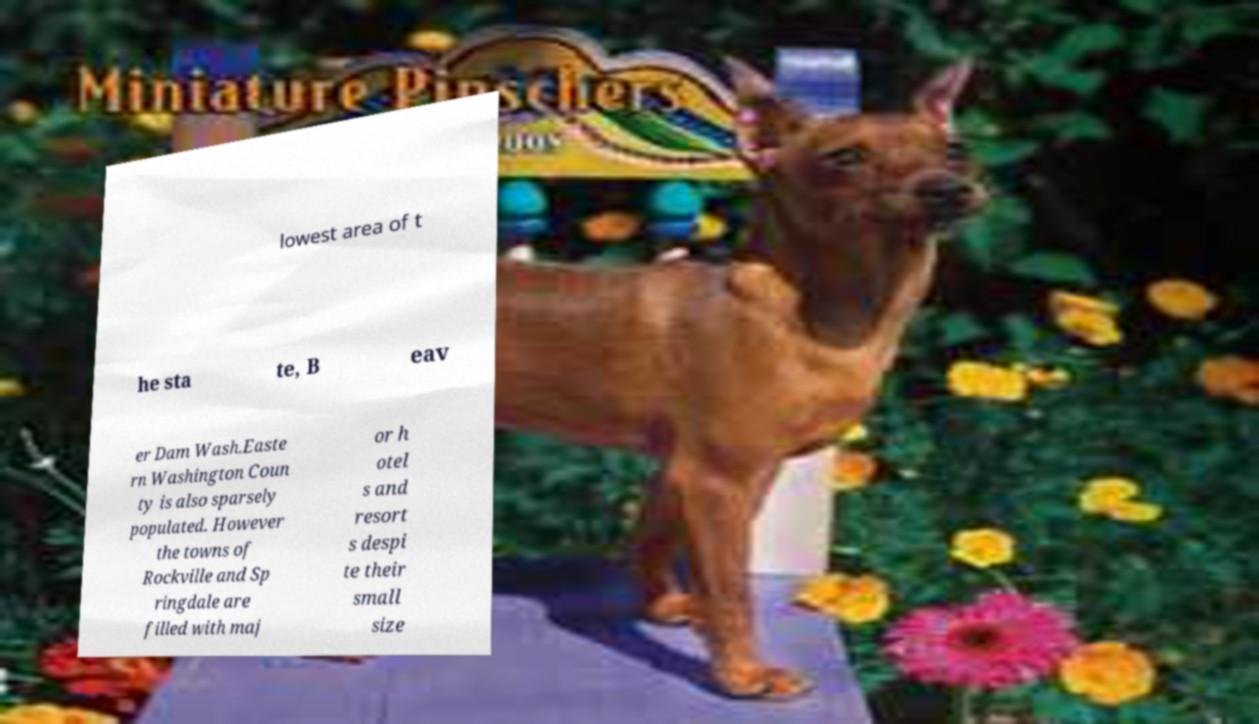For documentation purposes, I need the text within this image transcribed. Could you provide that? lowest area of t he sta te, B eav er Dam Wash.Easte rn Washington Coun ty is also sparsely populated. However the towns of Rockville and Sp ringdale are filled with maj or h otel s and resort s despi te their small size 